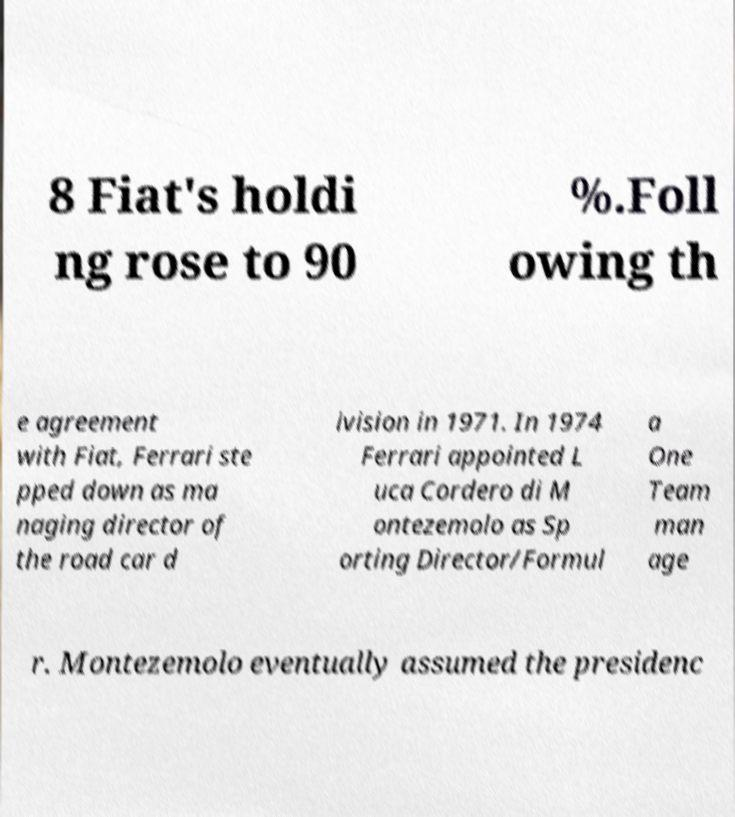What messages or text are displayed in this image? I need them in a readable, typed format. 8 Fiat's holdi ng rose to 90 %.Foll owing th e agreement with Fiat, Ferrari ste pped down as ma naging director of the road car d ivision in 1971. In 1974 Ferrari appointed L uca Cordero di M ontezemolo as Sp orting Director/Formul a One Team man age r. Montezemolo eventually assumed the presidenc 